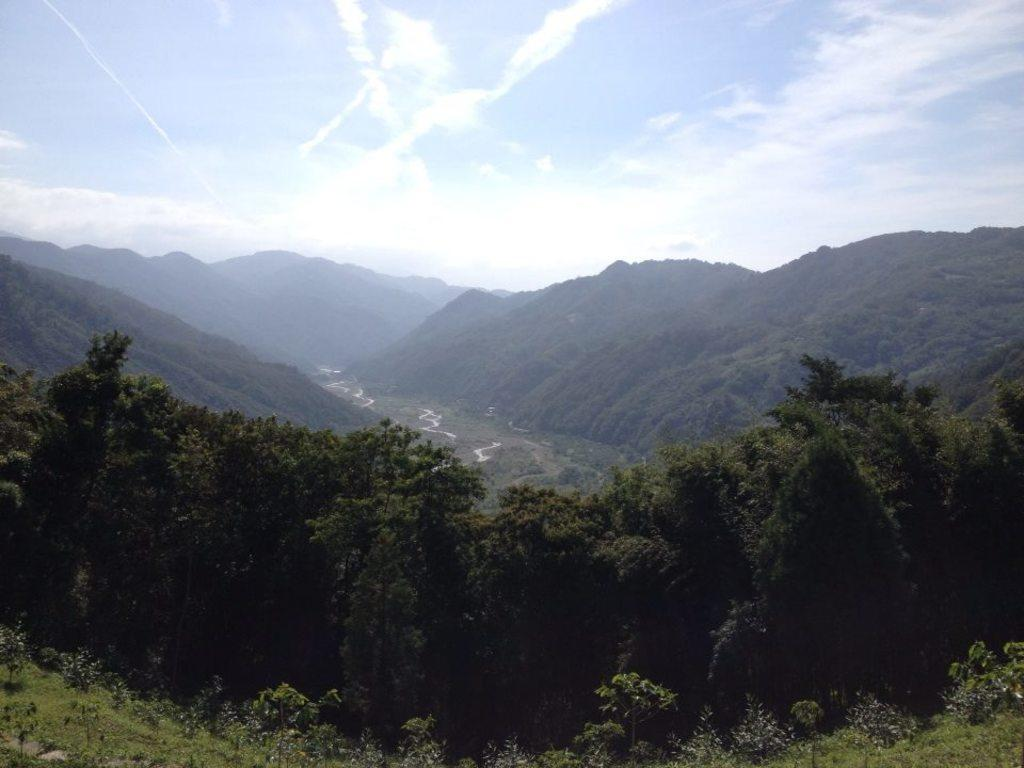What type of vegetation is at the bottom of the picture? There are trees at the bottom of the picture. What type of ground cover is visible in the image? Grass is visible in the image. What can be seen in the background of the image? There are hills in the background of the image. What is visible at the top of the image? The sky is visible at the top of the image. Can you tell me how many cubs are playing in the grass in the image? There are no cubs present in the image; it features trees, grass, hills, and the sky. What type of bird is perched on the tree in the image? There is no bird, specifically a robin, present in the image. 